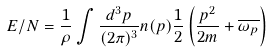<formula> <loc_0><loc_0><loc_500><loc_500>E / N = \frac { 1 } { \rho } \int \frac { d ^ { 3 } p } { ( 2 \pi ) ^ { 3 } } n ( p ) \frac { 1 } { 2 } \left ( \frac { p ^ { 2 } } { 2 m } + \overline { \omega _ { p } } \right )</formula> 